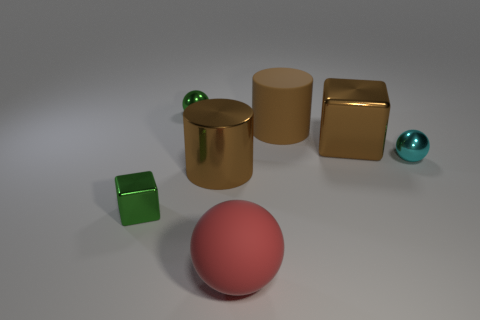What material is the red thing?
Offer a very short reply. Rubber. The sphere that is the same size as the brown cube is what color?
Ensure brevity in your answer.  Red. There is a large metallic thing that is the same color as the big cube; what shape is it?
Ensure brevity in your answer.  Cylinder. Is the shape of the cyan metal object the same as the red object?
Your response must be concise. Yes. What is the small object that is both behind the tiny green block and on the left side of the brown rubber cylinder made of?
Your answer should be compact. Metal. The brown rubber cylinder has what size?
Your answer should be very brief. Large. What is the color of the metallic thing that is the same shape as the brown rubber object?
Give a very brief answer. Brown. Are there any other things that are the same color as the rubber cylinder?
Make the answer very short. Yes. There is a cylinder that is left of the large matte ball; is it the same size as the matte thing that is in front of the cyan object?
Give a very brief answer. Yes. Is the number of small green cubes that are behind the big brown shiny cylinder the same as the number of big objects that are behind the green block?
Provide a succinct answer. No. 